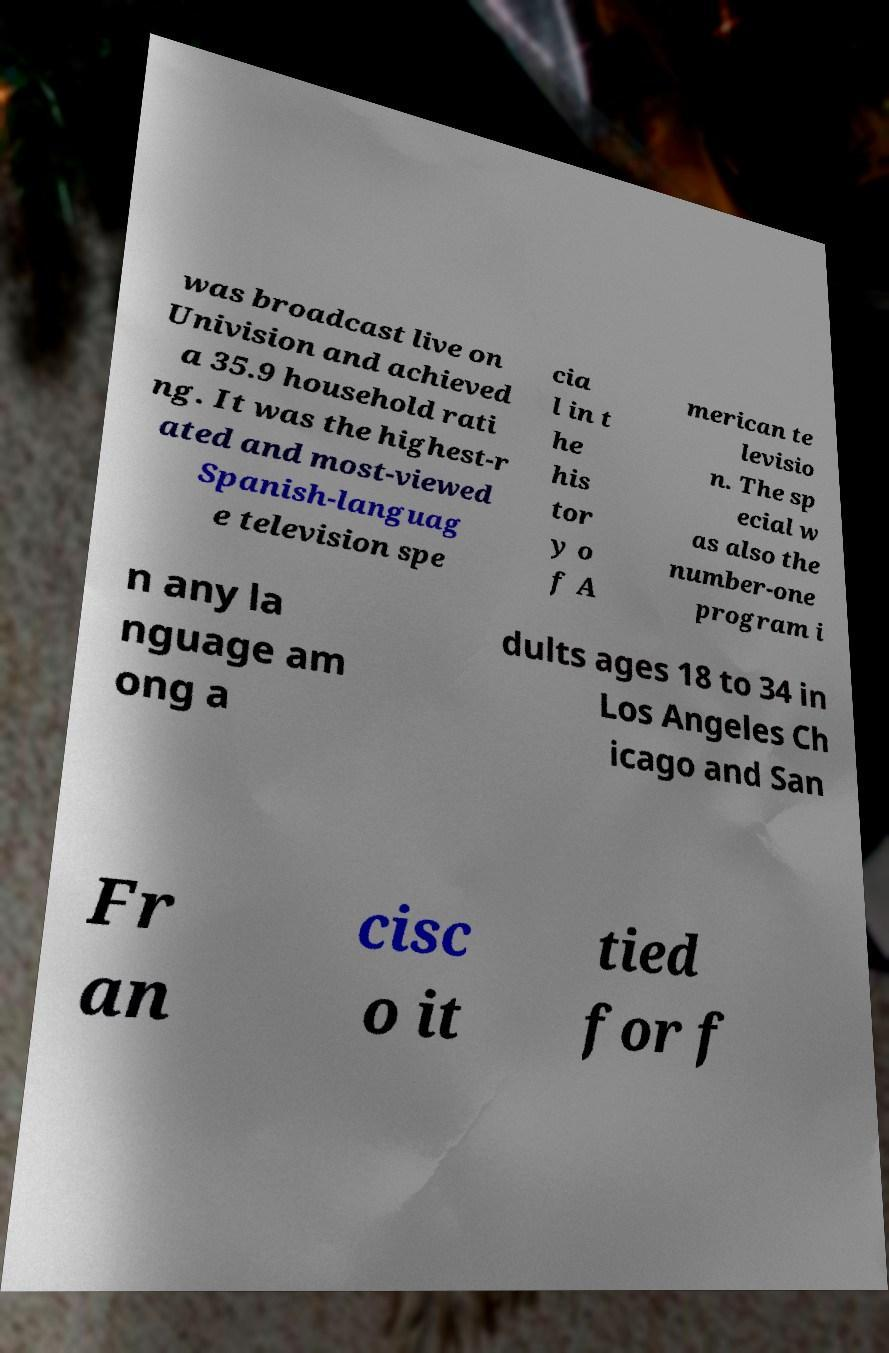I need the written content from this picture converted into text. Can you do that? was broadcast live on Univision and achieved a 35.9 household rati ng. It was the highest-r ated and most-viewed Spanish-languag e television spe cia l in t he his tor y o f A merican te levisio n. The sp ecial w as also the number-one program i n any la nguage am ong a dults ages 18 to 34 in Los Angeles Ch icago and San Fr an cisc o it tied for f 